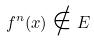<formula> <loc_0><loc_0><loc_500><loc_500>f ^ { n } ( x ) \notin E</formula> 